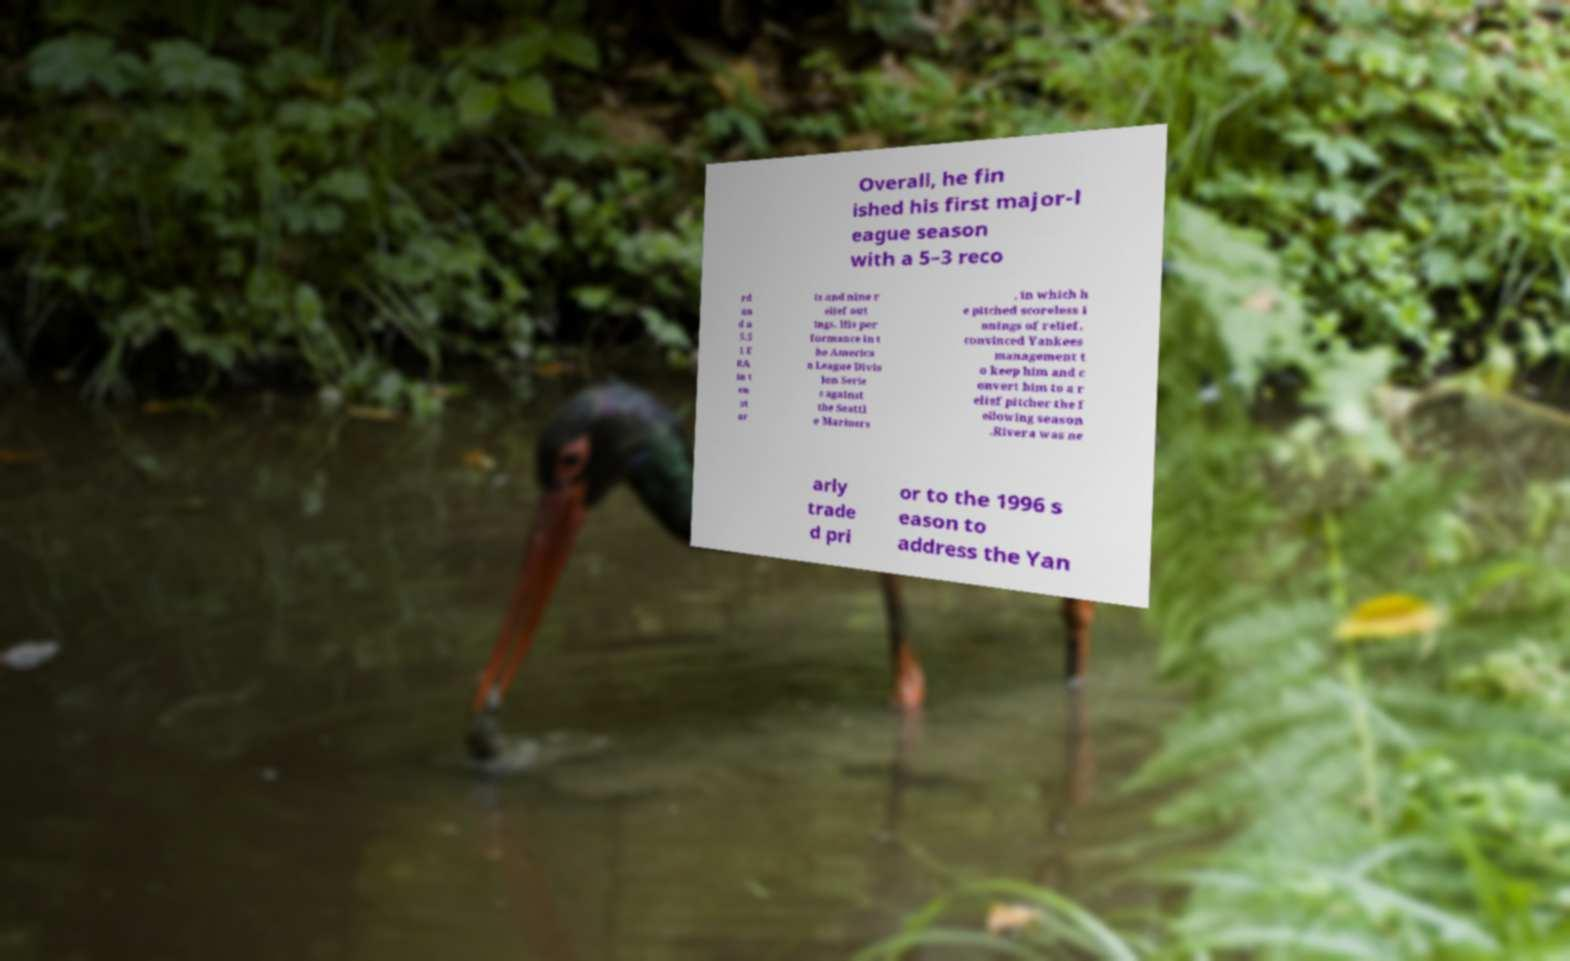Please identify and transcribe the text found in this image. Overall, he fin ished his first major-l eague season with a 5–3 reco rd an d a 5.5 1 E RA in t en st ar ts and nine r elief out ings. His per formance in t he America n League Divis ion Serie s against the Seattl e Mariners , in which h e pitched scoreless i nnings of relief, convinced Yankees management t o keep him and c onvert him to a r elief pitcher the f ollowing season .Rivera was ne arly trade d pri or to the 1996 s eason to address the Yan 